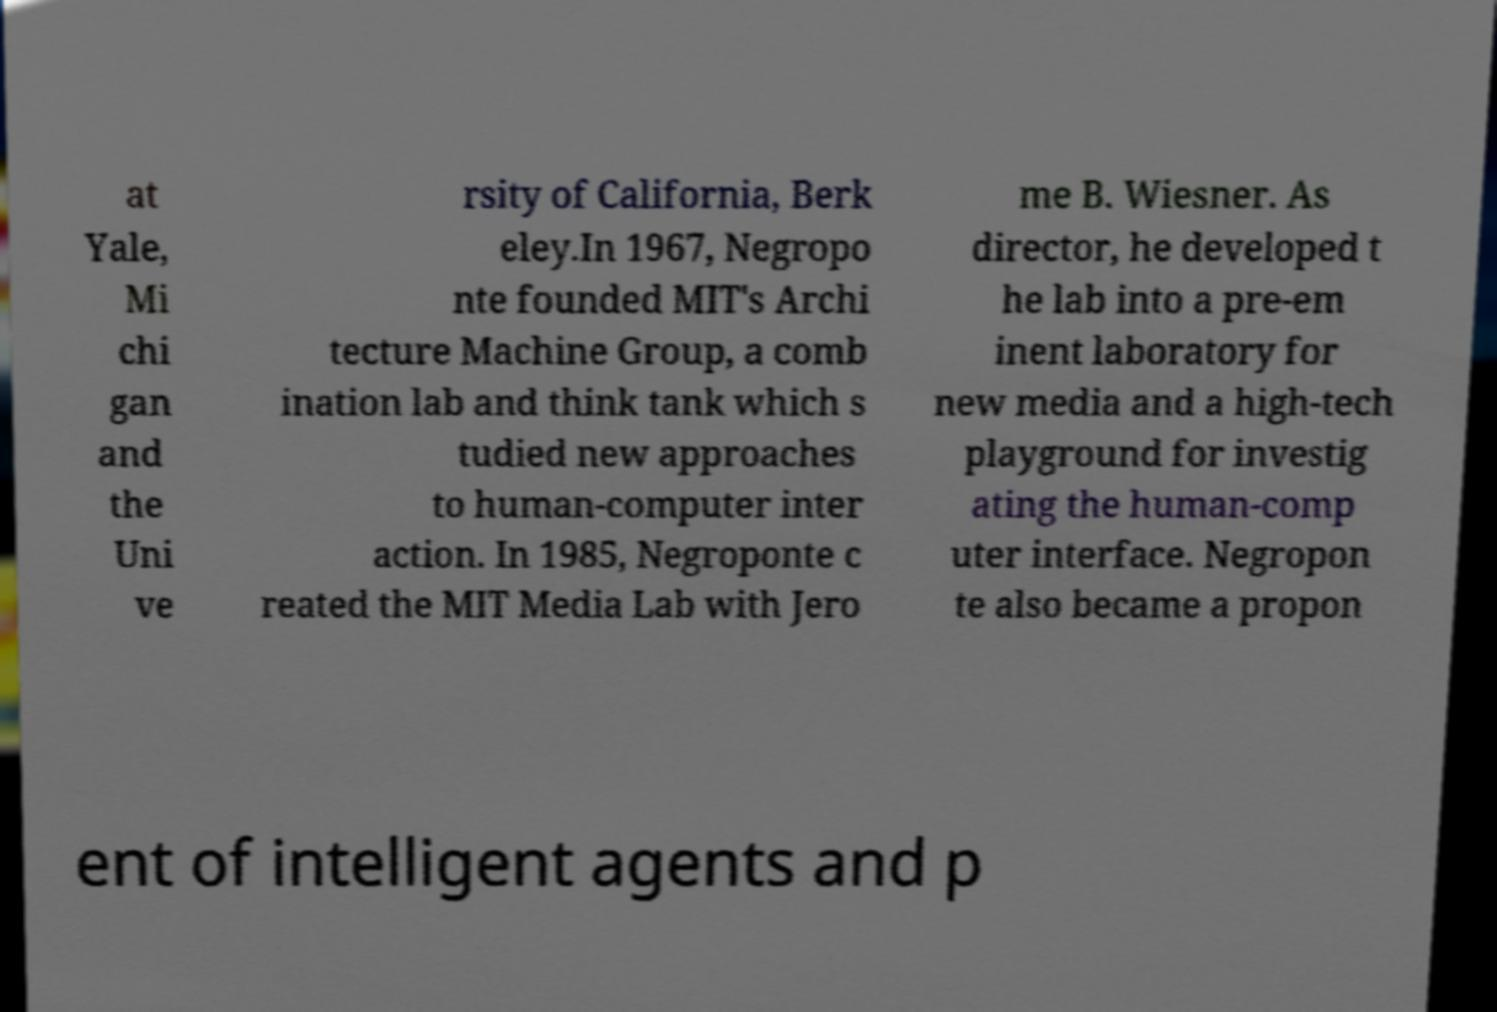Can you read and provide the text displayed in the image?This photo seems to have some interesting text. Can you extract and type it out for me? at Yale, Mi chi gan and the Uni ve rsity of California, Berk eley.In 1967, Negropo nte founded MIT's Archi tecture Machine Group, a comb ination lab and think tank which s tudied new approaches to human-computer inter action. In 1985, Negroponte c reated the MIT Media Lab with Jero me B. Wiesner. As director, he developed t he lab into a pre-em inent laboratory for new media and a high-tech playground for investig ating the human-comp uter interface. Negropon te also became a propon ent of intelligent agents and p 